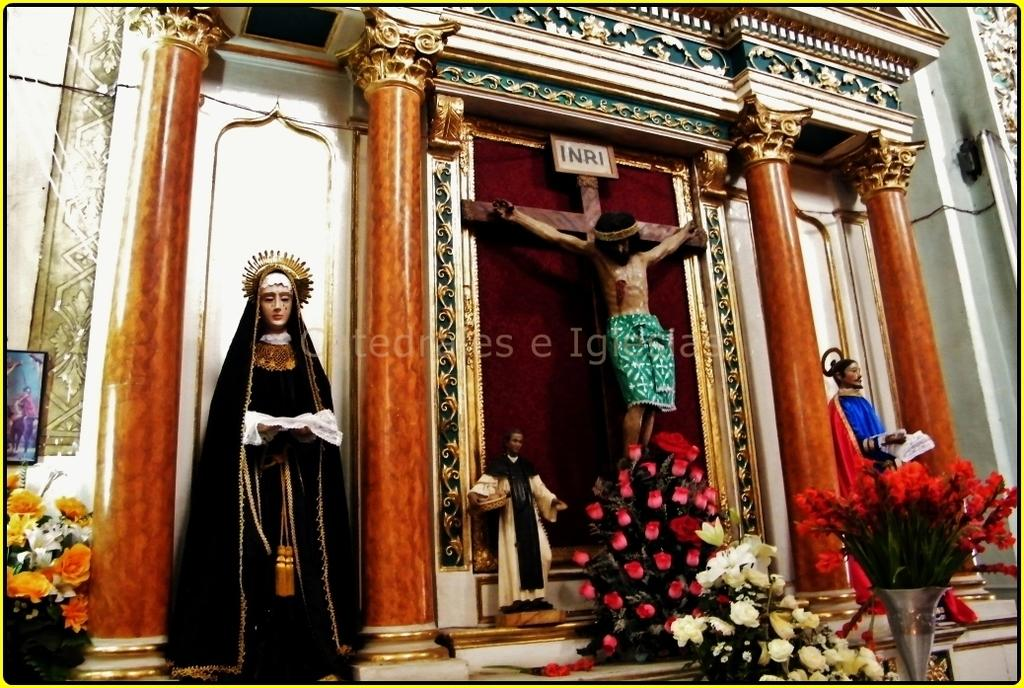<image>
Offer a succinct explanation of the picture presented. an altar church scene with Christ under and INRI sign 